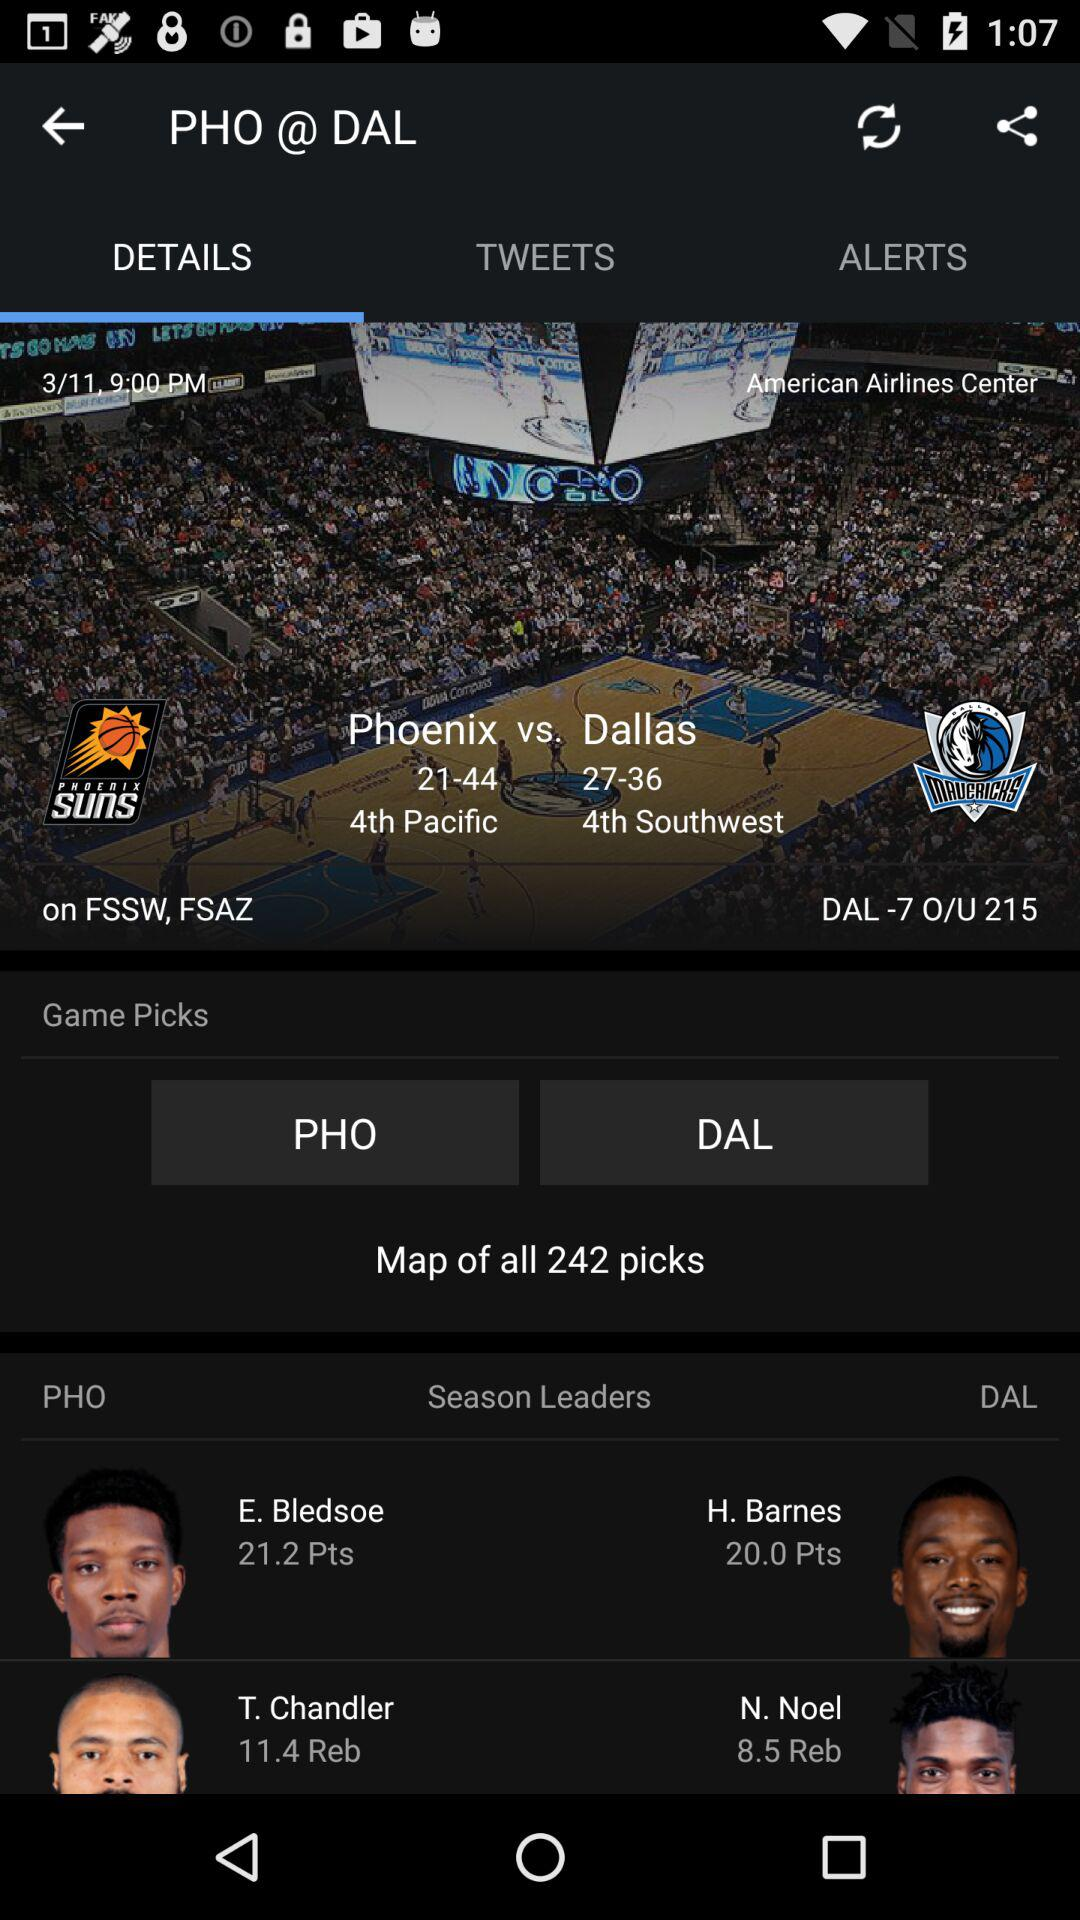The match is played between which two teams? The match is between "Phoenix" and "Dallas". 